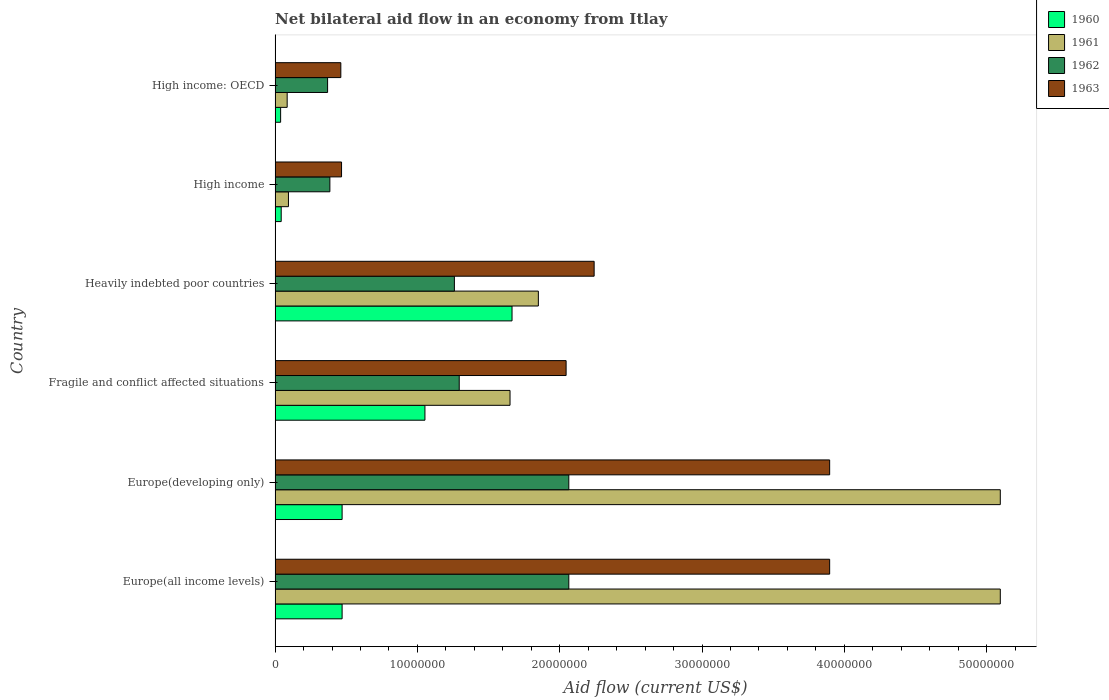Are the number of bars per tick equal to the number of legend labels?
Your answer should be very brief. Yes. How many bars are there on the 3rd tick from the bottom?
Keep it short and to the point. 4. What is the label of the 4th group of bars from the top?
Your response must be concise. Fragile and conflict affected situations. What is the net bilateral aid flow in 1961 in Heavily indebted poor countries?
Provide a succinct answer. 1.85e+07. Across all countries, what is the maximum net bilateral aid flow in 1963?
Ensure brevity in your answer.  3.90e+07. Across all countries, what is the minimum net bilateral aid flow in 1960?
Offer a terse response. 3.90e+05. In which country was the net bilateral aid flow in 1960 maximum?
Provide a succinct answer. Heavily indebted poor countries. In which country was the net bilateral aid flow in 1963 minimum?
Offer a very short reply. High income: OECD. What is the total net bilateral aid flow in 1962 in the graph?
Ensure brevity in your answer.  7.44e+07. What is the difference between the net bilateral aid flow in 1963 in Fragile and conflict affected situations and that in High income: OECD?
Provide a short and direct response. 1.58e+07. What is the difference between the net bilateral aid flow in 1960 in High income and the net bilateral aid flow in 1963 in Fragile and conflict affected situations?
Ensure brevity in your answer.  -2.00e+07. What is the average net bilateral aid flow in 1963 per country?
Keep it short and to the point. 2.17e+07. What is the difference between the net bilateral aid flow in 1962 and net bilateral aid flow in 1960 in High income?
Provide a short and direct response. 3.42e+06. What is the ratio of the net bilateral aid flow in 1961 in Europe(developing only) to that in Fragile and conflict affected situations?
Ensure brevity in your answer.  3.09. Is the difference between the net bilateral aid flow in 1962 in Europe(developing only) and High income greater than the difference between the net bilateral aid flow in 1960 in Europe(developing only) and High income?
Your answer should be very brief. Yes. What is the difference between the highest and the lowest net bilateral aid flow in 1960?
Your answer should be compact. 1.63e+07. What does the 3rd bar from the top in Europe(developing only) represents?
Your response must be concise. 1961. Is it the case that in every country, the sum of the net bilateral aid flow in 1960 and net bilateral aid flow in 1963 is greater than the net bilateral aid flow in 1962?
Provide a succinct answer. Yes. What is the difference between two consecutive major ticks on the X-axis?
Your response must be concise. 1.00e+07. Are the values on the major ticks of X-axis written in scientific E-notation?
Offer a very short reply. No. Does the graph contain any zero values?
Make the answer very short. No. Does the graph contain grids?
Ensure brevity in your answer.  No. How many legend labels are there?
Provide a short and direct response. 4. How are the legend labels stacked?
Ensure brevity in your answer.  Vertical. What is the title of the graph?
Offer a very short reply. Net bilateral aid flow in an economy from Itlay. What is the label or title of the X-axis?
Give a very brief answer. Aid flow (current US$). What is the Aid flow (current US$) of 1960 in Europe(all income levels)?
Your answer should be compact. 4.71e+06. What is the Aid flow (current US$) of 1961 in Europe(all income levels)?
Provide a succinct answer. 5.10e+07. What is the Aid flow (current US$) in 1962 in Europe(all income levels)?
Provide a short and direct response. 2.06e+07. What is the Aid flow (current US$) in 1963 in Europe(all income levels)?
Offer a terse response. 3.90e+07. What is the Aid flow (current US$) in 1960 in Europe(developing only)?
Provide a short and direct response. 4.71e+06. What is the Aid flow (current US$) in 1961 in Europe(developing only)?
Your response must be concise. 5.10e+07. What is the Aid flow (current US$) in 1962 in Europe(developing only)?
Give a very brief answer. 2.06e+07. What is the Aid flow (current US$) in 1963 in Europe(developing only)?
Your answer should be very brief. 3.90e+07. What is the Aid flow (current US$) in 1960 in Fragile and conflict affected situations?
Offer a very short reply. 1.05e+07. What is the Aid flow (current US$) of 1961 in Fragile and conflict affected situations?
Give a very brief answer. 1.65e+07. What is the Aid flow (current US$) of 1962 in Fragile and conflict affected situations?
Keep it short and to the point. 1.29e+07. What is the Aid flow (current US$) of 1963 in Fragile and conflict affected situations?
Make the answer very short. 2.04e+07. What is the Aid flow (current US$) of 1960 in Heavily indebted poor countries?
Ensure brevity in your answer.  1.66e+07. What is the Aid flow (current US$) in 1961 in Heavily indebted poor countries?
Give a very brief answer. 1.85e+07. What is the Aid flow (current US$) of 1962 in Heavily indebted poor countries?
Give a very brief answer. 1.26e+07. What is the Aid flow (current US$) of 1963 in Heavily indebted poor countries?
Provide a succinct answer. 2.24e+07. What is the Aid flow (current US$) in 1961 in High income?
Give a very brief answer. 9.40e+05. What is the Aid flow (current US$) of 1962 in High income?
Ensure brevity in your answer.  3.85e+06. What is the Aid flow (current US$) of 1963 in High income?
Make the answer very short. 4.67e+06. What is the Aid flow (current US$) in 1960 in High income: OECD?
Provide a short and direct response. 3.90e+05. What is the Aid flow (current US$) in 1961 in High income: OECD?
Your answer should be very brief. 8.50e+05. What is the Aid flow (current US$) of 1962 in High income: OECD?
Keep it short and to the point. 3.69e+06. What is the Aid flow (current US$) of 1963 in High income: OECD?
Your answer should be very brief. 4.62e+06. Across all countries, what is the maximum Aid flow (current US$) in 1960?
Ensure brevity in your answer.  1.66e+07. Across all countries, what is the maximum Aid flow (current US$) in 1961?
Provide a succinct answer. 5.10e+07. Across all countries, what is the maximum Aid flow (current US$) in 1962?
Ensure brevity in your answer.  2.06e+07. Across all countries, what is the maximum Aid flow (current US$) of 1963?
Provide a short and direct response. 3.90e+07. Across all countries, what is the minimum Aid flow (current US$) in 1961?
Ensure brevity in your answer.  8.50e+05. Across all countries, what is the minimum Aid flow (current US$) of 1962?
Make the answer very short. 3.69e+06. Across all countries, what is the minimum Aid flow (current US$) of 1963?
Give a very brief answer. 4.62e+06. What is the total Aid flow (current US$) of 1960 in the graph?
Keep it short and to the point. 3.74e+07. What is the total Aid flow (current US$) of 1961 in the graph?
Keep it short and to the point. 1.39e+08. What is the total Aid flow (current US$) of 1962 in the graph?
Your answer should be compact. 7.44e+07. What is the total Aid flow (current US$) in 1963 in the graph?
Make the answer very short. 1.30e+08. What is the difference between the Aid flow (current US$) in 1960 in Europe(all income levels) and that in Europe(developing only)?
Offer a very short reply. 0. What is the difference between the Aid flow (current US$) of 1962 in Europe(all income levels) and that in Europe(developing only)?
Keep it short and to the point. 0. What is the difference between the Aid flow (current US$) in 1960 in Europe(all income levels) and that in Fragile and conflict affected situations?
Offer a terse response. -5.82e+06. What is the difference between the Aid flow (current US$) of 1961 in Europe(all income levels) and that in Fragile and conflict affected situations?
Offer a terse response. 3.44e+07. What is the difference between the Aid flow (current US$) of 1962 in Europe(all income levels) and that in Fragile and conflict affected situations?
Your response must be concise. 7.70e+06. What is the difference between the Aid flow (current US$) of 1963 in Europe(all income levels) and that in Fragile and conflict affected situations?
Provide a succinct answer. 1.85e+07. What is the difference between the Aid flow (current US$) in 1960 in Europe(all income levels) and that in Heavily indebted poor countries?
Ensure brevity in your answer.  -1.19e+07. What is the difference between the Aid flow (current US$) in 1961 in Europe(all income levels) and that in Heavily indebted poor countries?
Your answer should be compact. 3.25e+07. What is the difference between the Aid flow (current US$) in 1962 in Europe(all income levels) and that in Heavily indebted poor countries?
Your answer should be very brief. 8.04e+06. What is the difference between the Aid flow (current US$) in 1963 in Europe(all income levels) and that in Heavily indebted poor countries?
Offer a terse response. 1.66e+07. What is the difference between the Aid flow (current US$) of 1960 in Europe(all income levels) and that in High income?
Ensure brevity in your answer.  4.28e+06. What is the difference between the Aid flow (current US$) in 1961 in Europe(all income levels) and that in High income?
Provide a succinct answer. 5.00e+07. What is the difference between the Aid flow (current US$) in 1962 in Europe(all income levels) and that in High income?
Provide a short and direct response. 1.68e+07. What is the difference between the Aid flow (current US$) in 1963 in Europe(all income levels) and that in High income?
Give a very brief answer. 3.43e+07. What is the difference between the Aid flow (current US$) in 1960 in Europe(all income levels) and that in High income: OECD?
Your response must be concise. 4.32e+06. What is the difference between the Aid flow (current US$) of 1961 in Europe(all income levels) and that in High income: OECD?
Your answer should be very brief. 5.01e+07. What is the difference between the Aid flow (current US$) in 1962 in Europe(all income levels) and that in High income: OECD?
Ensure brevity in your answer.  1.70e+07. What is the difference between the Aid flow (current US$) of 1963 in Europe(all income levels) and that in High income: OECD?
Offer a very short reply. 3.44e+07. What is the difference between the Aid flow (current US$) of 1960 in Europe(developing only) and that in Fragile and conflict affected situations?
Your answer should be very brief. -5.82e+06. What is the difference between the Aid flow (current US$) of 1961 in Europe(developing only) and that in Fragile and conflict affected situations?
Your answer should be very brief. 3.44e+07. What is the difference between the Aid flow (current US$) in 1962 in Europe(developing only) and that in Fragile and conflict affected situations?
Your answer should be very brief. 7.70e+06. What is the difference between the Aid flow (current US$) of 1963 in Europe(developing only) and that in Fragile and conflict affected situations?
Keep it short and to the point. 1.85e+07. What is the difference between the Aid flow (current US$) of 1960 in Europe(developing only) and that in Heavily indebted poor countries?
Your answer should be compact. -1.19e+07. What is the difference between the Aid flow (current US$) in 1961 in Europe(developing only) and that in Heavily indebted poor countries?
Keep it short and to the point. 3.25e+07. What is the difference between the Aid flow (current US$) in 1962 in Europe(developing only) and that in Heavily indebted poor countries?
Provide a short and direct response. 8.04e+06. What is the difference between the Aid flow (current US$) in 1963 in Europe(developing only) and that in Heavily indebted poor countries?
Your answer should be compact. 1.66e+07. What is the difference between the Aid flow (current US$) of 1960 in Europe(developing only) and that in High income?
Your response must be concise. 4.28e+06. What is the difference between the Aid flow (current US$) in 1961 in Europe(developing only) and that in High income?
Your answer should be very brief. 5.00e+07. What is the difference between the Aid flow (current US$) in 1962 in Europe(developing only) and that in High income?
Keep it short and to the point. 1.68e+07. What is the difference between the Aid flow (current US$) of 1963 in Europe(developing only) and that in High income?
Give a very brief answer. 3.43e+07. What is the difference between the Aid flow (current US$) of 1960 in Europe(developing only) and that in High income: OECD?
Ensure brevity in your answer.  4.32e+06. What is the difference between the Aid flow (current US$) in 1961 in Europe(developing only) and that in High income: OECD?
Your response must be concise. 5.01e+07. What is the difference between the Aid flow (current US$) in 1962 in Europe(developing only) and that in High income: OECD?
Offer a terse response. 1.70e+07. What is the difference between the Aid flow (current US$) of 1963 in Europe(developing only) and that in High income: OECD?
Give a very brief answer. 3.44e+07. What is the difference between the Aid flow (current US$) of 1960 in Fragile and conflict affected situations and that in Heavily indebted poor countries?
Offer a very short reply. -6.12e+06. What is the difference between the Aid flow (current US$) in 1961 in Fragile and conflict affected situations and that in Heavily indebted poor countries?
Keep it short and to the point. -1.99e+06. What is the difference between the Aid flow (current US$) in 1963 in Fragile and conflict affected situations and that in Heavily indebted poor countries?
Give a very brief answer. -1.97e+06. What is the difference between the Aid flow (current US$) in 1960 in Fragile and conflict affected situations and that in High income?
Give a very brief answer. 1.01e+07. What is the difference between the Aid flow (current US$) in 1961 in Fragile and conflict affected situations and that in High income?
Make the answer very short. 1.56e+07. What is the difference between the Aid flow (current US$) in 1962 in Fragile and conflict affected situations and that in High income?
Provide a short and direct response. 9.09e+06. What is the difference between the Aid flow (current US$) in 1963 in Fragile and conflict affected situations and that in High income?
Ensure brevity in your answer.  1.58e+07. What is the difference between the Aid flow (current US$) of 1960 in Fragile and conflict affected situations and that in High income: OECD?
Keep it short and to the point. 1.01e+07. What is the difference between the Aid flow (current US$) in 1961 in Fragile and conflict affected situations and that in High income: OECD?
Keep it short and to the point. 1.57e+07. What is the difference between the Aid flow (current US$) of 1962 in Fragile and conflict affected situations and that in High income: OECD?
Offer a very short reply. 9.25e+06. What is the difference between the Aid flow (current US$) of 1963 in Fragile and conflict affected situations and that in High income: OECD?
Give a very brief answer. 1.58e+07. What is the difference between the Aid flow (current US$) of 1960 in Heavily indebted poor countries and that in High income?
Offer a very short reply. 1.62e+07. What is the difference between the Aid flow (current US$) in 1961 in Heavily indebted poor countries and that in High income?
Offer a terse response. 1.76e+07. What is the difference between the Aid flow (current US$) in 1962 in Heavily indebted poor countries and that in High income?
Your answer should be compact. 8.75e+06. What is the difference between the Aid flow (current US$) of 1963 in Heavily indebted poor countries and that in High income?
Your response must be concise. 1.78e+07. What is the difference between the Aid flow (current US$) of 1960 in Heavily indebted poor countries and that in High income: OECD?
Ensure brevity in your answer.  1.63e+07. What is the difference between the Aid flow (current US$) of 1961 in Heavily indebted poor countries and that in High income: OECD?
Provide a succinct answer. 1.76e+07. What is the difference between the Aid flow (current US$) in 1962 in Heavily indebted poor countries and that in High income: OECD?
Ensure brevity in your answer.  8.91e+06. What is the difference between the Aid flow (current US$) of 1963 in Heavily indebted poor countries and that in High income: OECD?
Ensure brevity in your answer.  1.78e+07. What is the difference between the Aid flow (current US$) in 1961 in High income and that in High income: OECD?
Provide a succinct answer. 9.00e+04. What is the difference between the Aid flow (current US$) of 1963 in High income and that in High income: OECD?
Your answer should be compact. 5.00e+04. What is the difference between the Aid flow (current US$) of 1960 in Europe(all income levels) and the Aid flow (current US$) of 1961 in Europe(developing only)?
Your answer should be very brief. -4.62e+07. What is the difference between the Aid flow (current US$) of 1960 in Europe(all income levels) and the Aid flow (current US$) of 1962 in Europe(developing only)?
Provide a succinct answer. -1.59e+07. What is the difference between the Aid flow (current US$) in 1960 in Europe(all income levels) and the Aid flow (current US$) in 1963 in Europe(developing only)?
Your answer should be compact. -3.43e+07. What is the difference between the Aid flow (current US$) in 1961 in Europe(all income levels) and the Aid flow (current US$) in 1962 in Europe(developing only)?
Keep it short and to the point. 3.03e+07. What is the difference between the Aid flow (current US$) of 1961 in Europe(all income levels) and the Aid flow (current US$) of 1963 in Europe(developing only)?
Your answer should be compact. 1.20e+07. What is the difference between the Aid flow (current US$) in 1962 in Europe(all income levels) and the Aid flow (current US$) in 1963 in Europe(developing only)?
Your answer should be very brief. -1.83e+07. What is the difference between the Aid flow (current US$) of 1960 in Europe(all income levels) and the Aid flow (current US$) of 1961 in Fragile and conflict affected situations?
Make the answer very short. -1.18e+07. What is the difference between the Aid flow (current US$) of 1960 in Europe(all income levels) and the Aid flow (current US$) of 1962 in Fragile and conflict affected situations?
Make the answer very short. -8.23e+06. What is the difference between the Aid flow (current US$) in 1960 in Europe(all income levels) and the Aid flow (current US$) in 1963 in Fragile and conflict affected situations?
Keep it short and to the point. -1.57e+07. What is the difference between the Aid flow (current US$) in 1961 in Europe(all income levels) and the Aid flow (current US$) in 1962 in Fragile and conflict affected situations?
Ensure brevity in your answer.  3.80e+07. What is the difference between the Aid flow (current US$) in 1961 in Europe(all income levels) and the Aid flow (current US$) in 1963 in Fragile and conflict affected situations?
Provide a short and direct response. 3.05e+07. What is the difference between the Aid flow (current US$) of 1962 in Europe(all income levels) and the Aid flow (current US$) of 1963 in Fragile and conflict affected situations?
Provide a succinct answer. 1.90e+05. What is the difference between the Aid flow (current US$) in 1960 in Europe(all income levels) and the Aid flow (current US$) in 1961 in Heavily indebted poor countries?
Your response must be concise. -1.38e+07. What is the difference between the Aid flow (current US$) in 1960 in Europe(all income levels) and the Aid flow (current US$) in 1962 in Heavily indebted poor countries?
Your answer should be very brief. -7.89e+06. What is the difference between the Aid flow (current US$) in 1960 in Europe(all income levels) and the Aid flow (current US$) in 1963 in Heavily indebted poor countries?
Your answer should be very brief. -1.77e+07. What is the difference between the Aid flow (current US$) of 1961 in Europe(all income levels) and the Aid flow (current US$) of 1962 in Heavily indebted poor countries?
Your answer should be very brief. 3.84e+07. What is the difference between the Aid flow (current US$) in 1961 in Europe(all income levels) and the Aid flow (current US$) in 1963 in Heavily indebted poor countries?
Give a very brief answer. 2.85e+07. What is the difference between the Aid flow (current US$) in 1962 in Europe(all income levels) and the Aid flow (current US$) in 1963 in Heavily indebted poor countries?
Your answer should be very brief. -1.78e+06. What is the difference between the Aid flow (current US$) in 1960 in Europe(all income levels) and the Aid flow (current US$) in 1961 in High income?
Make the answer very short. 3.77e+06. What is the difference between the Aid flow (current US$) in 1960 in Europe(all income levels) and the Aid flow (current US$) in 1962 in High income?
Offer a terse response. 8.60e+05. What is the difference between the Aid flow (current US$) in 1960 in Europe(all income levels) and the Aid flow (current US$) in 1963 in High income?
Offer a very short reply. 4.00e+04. What is the difference between the Aid flow (current US$) of 1961 in Europe(all income levels) and the Aid flow (current US$) of 1962 in High income?
Offer a very short reply. 4.71e+07. What is the difference between the Aid flow (current US$) of 1961 in Europe(all income levels) and the Aid flow (current US$) of 1963 in High income?
Provide a succinct answer. 4.63e+07. What is the difference between the Aid flow (current US$) of 1962 in Europe(all income levels) and the Aid flow (current US$) of 1963 in High income?
Your answer should be very brief. 1.60e+07. What is the difference between the Aid flow (current US$) in 1960 in Europe(all income levels) and the Aid flow (current US$) in 1961 in High income: OECD?
Your answer should be very brief. 3.86e+06. What is the difference between the Aid flow (current US$) in 1960 in Europe(all income levels) and the Aid flow (current US$) in 1962 in High income: OECD?
Provide a succinct answer. 1.02e+06. What is the difference between the Aid flow (current US$) in 1960 in Europe(all income levels) and the Aid flow (current US$) in 1963 in High income: OECD?
Your response must be concise. 9.00e+04. What is the difference between the Aid flow (current US$) of 1961 in Europe(all income levels) and the Aid flow (current US$) of 1962 in High income: OECD?
Offer a very short reply. 4.73e+07. What is the difference between the Aid flow (current US$) in 1961 in Europe(all income levels) and the Aid flow (current US$) in 1963 in High income: OECD?
Provide a succinct answer. 4.63e+07. What is the difference between the Aid flow (current US$) in 1962 in Europe(all income levels) and the Aid flow (current US$) in 1963 in High income: OECD?
Ensure brevity in your answer.  1.60e+07. What is the difference between the Aid flow (current US$) in 1960 in Europe(developing only) and the Aid flow (current US$) in 1961 in Fragile and conflict affected situations?
Offer a very short reply. -1.18e+07. What is the difference between the Aid flow (current US$) of 1960 in Europe(developing only) and the Aid flow (current US$) of 1962 in Fragile and conflict affected situations?
Keep it short and to the point. -8.23e+06. What is the difference between the Aid flow (current US$) of 1960 in Europe(developing only) and the Aid flow (current US$) of 1963 in Fragile and conflict affected situations?
Offer a very short reply. -1.57e+07. What is the difference between the Aid flow (current US$) in 1961 in Europe(developing only) and the Aid flow (current US$) in 1962 in Fragile and conflict affected situations?
Offer a very short reply. 3.80e+07. What is the difference between the Aid flow (current US$) in 1961 in Europe(developing only) and the Aid flow (current US$) in 1963 in Fragile and conflict affected situations?
Keep it short and to the point. 3.05e+07. What is the difference between the Aid flow (current US$) of 1960 in Europe(developing only) and the Aid flow (current US$) of 1961 in Heavily indebted poor countries?
Offer a very short reply. -1.38e+07. What is the difference between the Aid flow (current US$) in 1960 in Europe(developing only) and the Aid flow (current US$) in 1962 in Heavily indebted poor countries?
Ensure brevity in your answer.  -7.89e+06. What is the difference between the Aid flow (current US$) in 1960 in Europe(developing only) and the Aid flow (current US$) in 1963 in Heavily indebted poor countries?
Your response must be concise. -1.77e+07. What is the difference between the Aid flow (current US$) of 1961 in Europe(developing only) and the Aid flow (current US$) of 1962 in Heavily indebted poor countries?
Give a very brief answer. 3.84e+07. What is the difference between the Aid flow (current US$) of 1961 in Europe(developing only) and the Aid flow (current US$) of 1963 in Heavily indebted poor countries?
Give a very brief answer. 2.85e+07. What is the difference between the Aid flow (current US$) in 1962 in Europe(developing only) and the Aid flow (current US$) in 1963 in Heavily indebted poor countries?
Give a very brief answer. -1.78e+06. What is the difference between the Aid flow (current US$) of 1960 in Europe(developing only) and the Aid flow (current US$) of 1961 in High income?
Make the answer very short. 3.77e+06. What is the difference between the Aid flow (current US$) in 1960 in Europe(developing only) and the Aid flow (current US$) in 1962 in High income?
Your answer should be very brief. 8.60e+05. What is the difference between the Aid flow (current US$) of 1960 in Europe(developing only) and the Aid flow (current US$) of 1963 in High income?
Provide a short and direct response. 4.00e+04. What is the difference between the Aid flow (current US$) of 1961 in Europe(developing only) and the Aid flow (current US$) of 1962 in High income?
Offer a very short reply. 4.71e+07. What is the difference between the Aid flow (current US$) in 1961 in Europe(developing only) and the Aid flow (current US$) in 1963 in High income?
Keep it short and to the point. 4.63e+07. What is the difference between the Aid flow (current US$) of 1962 in Europe(developing only) and the Aid flow (current US$) of 1963 in High income?
Offer a very short reply. 1.60e+07. What is the difference between the Aid flow (current US$) in 1960 in Europe(developing only) and the Aid flow (current US$) in 1961 in High income: OECD?
Provide a short and direct response. 3.86e+06. What is the difference between the Aid flow (current US$) in 1960 in Europe(developing only) and the Aid flow (current US$) in 1962 in High income: OECD?
Ensure brevity in your answer.  1.02e+06. What is the difference between the Aid flow (current US$) of 1960 in Europe(developing only) and the Aid flow (current US$) of 1963 in High income: OECD?
Your response must be concise. 9.00e+04. What is the difference between the Aid flow (current US$) of 1961 in Europe(developing only) and the Aid flow (current US$) of 1962 in High income: OECD?
Your answer should be very brief. 4.73e+07. What is the difference between the Aid flow (current US$) of 1961 in Europe(developing only) and the Aid flow (current US$) of 1963 in High income: OECD?
Keep it short and to the point. 4.63e+07. What is the difference between the Aid flow (current US$) in 1962 in Europe(developing only) and the Aid flow (current US$) in 1963 in High income: OECD?
Your answer should be compact. 1.60e+07. What is the difference between the Aid flow (current US$) of 1960 in Fragile and conflict affected situations and the Aid flow (current US$) of 1961 in Heavily indebted poor countries?
Make the answer very short. -7.97e+06. What is the difference between the Aid flow (current US$) in 1960 in Fragile and conflict affected situations and the Aid flow (current US$) in 1962 in Heavily indebted poor countries?
Provide a short and direct response. -2.07e+06. What is the difference between the Aid flow (current US$) of 1960 in Fragile and conflict affected situations and the Aid flow (current US$) of 1963 in Heavily indebted poor countries?
Ensure brevity in your answer.  -1.19e+07. What is the difference between the Aid flow (current US$) of 1961 in Fragile and conflict affected situations and the Aid flow (current US$) of 1962 in Heavily indebted poor countries?
Offer a terse response. 3.91e+06. What is the difference between the Aid flow (current US$) of 1961 in Fragile and conflict affected situations and the Aid flow (current US$) of 1963 in Heavily indebted poor countries?
Your answer should be very brief. -5.91e+06. What is the difference between the Aid flow (current US$) of 1962 in Fragile and conflict affected situations and the Aid flow (current US$) of 1963 in Heavily indebted poor countries?
Keep it short and to the point. -9.48e+06. What is the difference between the Aid flow (current US$) of 1960 in Fragile and conflict affected situations and the Aid flow (current US$) of 1961 in High income?
Provide a succinct answer. 9.59e+06. What is the difference between the Aid flow (current US$) of 1960 in Fragile and conflict affected situations and the Aid flow (current US$) of 1962 in High income?
Offer a very short reply. 6.68e+06. What is the difference between the Aid flow (current US$) of 1960 in Fragile and conflict affected situations and the Aid flow (current US$) of 1963 in High income?
Give a very brief answer. 5.86e+06. What is the difference between the Aid flow (current US$) in 1961 in Fragile and conflict affected situations and the Aid flow (current US$) in 1962 in High income?
Keep it short and to the point. 1.27e+07. What is the difference between the Aid flow (current US$) of 1961 in Fragile and conflict affected situations and the Aid flow (current US$) of 1963 in High income?
Provide a short and direct response. 1.18e+07. What is the difference between the Aid flow (current US$) of 1962 in Fragile and conflict affected situations and the Aid flow (current US$) of 1963 in High income?
Your answer should be compact. 8.27e+06. What is the difference between the Aid flow (current US$) of 1960 in Fragile and conflict affected situations and the Aid flow (current US$) of 1961 in High income: OECD?
Your answer should be compact. 9.68e+06. What is the difference between the Aid flow (current US$) in 1960 in Fragile and conflict affected situations and the Aid flow (current US$) in 1962 in High income: OECD?
Your answer should be very brief. 6.84e+06. What is the difference between the Aid flow (current US$) in 1960 in Fragile and conflict affected situations and the Aid flow (current US$) in 1963 in High income: OECD?
Offer a terse response. 5.91e+06. What is the difference between the Aid flow (current US$) of 1961 in Fragile and conflict affected situations and the Aid flow (current US$) of 1962 in High income: OECD?
Your response must be concise. 1.28e+07. What is the difference between the Aid flow (current US$) of 1961 in Fragile and conflict affected situations and the Aid flow (current US$) of 1963 in High income: OECD?
Offer a terse response. 1.19e+07. What is the difference between the Aid flow (current US$) in 1962 in Fragile and conflict affected situations and the Aid flow (current US$) in 1963 in High income: OECD?
Ensure brevity in your answer.  8.32e+06. What is the difference between the Aid flow (current US$) of 1960 in Heavily indebted poor countries and the Aid flow (current US$) of 1961 in High income?
Offer a very short reply. 1.57e+07. What is the difference between the Aid flow (current US$) in 1960 in Heavily indebted poor countries and the Aid flow (current US$) in 1962 in High income?
Provide a succinct answer. 1.28e+07. What is the difference between the Aid flow (current US$) of 1960 in Heavily indebted poor countries and the Aid flow (current US$) of 1963 in High income?
Ensure brevity in your answer.  1.20e+07. What is the difference between the Aid flow (current US$) in 1961 in Heavily indebted poor countries and the Aid flow (current US$) in 1962 in High income?
Your response must be concise. 1.46e+07. What is the difference between the Aid flow (current US$) of 1961 in Heavily indebted poor countries and the Aid flow (current US$) of 1963 in High income?
Ensure brevity in your answer.  1.38e+07. What is the difference between the Aid flow (current US$) in 1962 in Heavily indebted poor countries and the Aid flow (current US$) in 1963 in High income?
Offer a very short reply. 7.93e+06. What is the difference between the Aid flow (current US$) of 1960 in Heavily indebted poor countries and the Aid flow (current US$) of 1961 in High income: OECD?
Your answer should be very brief. 1.58e+07. What is the difference between the Aid flow (current US$) in 1960 in Heavily indebted poor countries and the Aid flow (current US$) in 1962 in High income: OECD?
Your response must be concise. 1.30e+07. What is the difference between the Aid flow (current US$) in 1960 in Heavily indebted poor countries and the Aid flow (current US$) in 1963 in High income: OECD?
Your answer should be compact. 1.20e+07. What is the difference between the Aid flow (current US$) in 1961 in Heavily indebted poor countries and the Aid flow (current US$) in 1962 in High income: OECD?
Provide a short and direct response. 1.48e+07. What is the difference between the Aid flow (current US$) of 1961 in Heavily indebted poor countries and the Aid flow (current US$) of 1963 in High income: OECD?
Provide a succinct answer. 1.39e+07. What is the difference between the Aid flow (current US$) of 1962 in Heavily indebted poor countries and the Aid flow (current US$) of 1963 in High income: OECD?
Ensure brevity in your answer.  7.98e+06. What is the difference between the Aid flow (current US$) in 1960 in High income and the Aid flow (current US$) in 1961 in High income: OECD?
Provide a succinct answer. -4.20e+05. What is the difference between the Aid flow (current US$) in 1960 in High income and the Aid flow (current US$) in 1962 in High income: OECD?
Your answer should be compact. -3.26e+06. What is the difference between the Aid flow (current US$) of 1960 in High income and the Aid flow (current US$) of 1963 in High income: OECD?
Your response must be concise. -4.19e+06. What is the difference between the Aid flow (current US$) of 1961 in High income and the Aid flow (current US$) of 1962 in High income: OECD?
Give a very brief answer. -2.75e+06. What is the difference between the Aid flow (current US$) in 1961 in High income and the Aid flow (current US$) in 1963 in High income: OECD?
Your response must be concise. -3.68e+06. What is the difference between the Aid flow (current US$) in 1962 in High income and the Aid flow (current US$) in 1963 in High income: OECD?
Keep it short and to the point. -7.70e+05. What is the average Aid flow (current US$) in 1960 per country?
Ensure brevity in your answer.  6.24e+06. What is the average Aid flow (current US$) of 1961 per country?
Ensure brevity in your answer.  2.31e+07. What is the average Aid flow (current US$) of 1962 per country?
Keep it short and to the point. 1.24e+07. What is the average Aid flow (current US$) in 1963 per country?
Make the answer very short. 2.17e+07. What is the difference between the Aid flow (current US$) in 1960 and Aid flow (current US$) in 1961 in Europe(all income levels)?
Provide a succinct answer. -4.62e+07. What is the difference between the Aid flow (current US$) of 1960 and Aid flow (current US$) of 1962 in Europe(all income levels)?
Offer a terse response. -1.59e+07. What is the difference between the Aid flow (current US$) in 1960 and Aid flow (current US$) in 1963 in Europe(all income levels)?
Give a very brief answer. -3.43e+07. What is the difference between the Aid flow (current US$) in 1961 and Aid flow (current US$) in 1962 in Europe(all income levels)?
Make the answer very short. 3.03e+07. What is the difference between the Aid flow (current US$) in 1961 and Aid flow (current US$) in 1963 in Europe(all income levels)?
Your response must be concise. 1.20e+07. What is the difference between the Aid flow (current US$) of 1962 and Aid flow (current US$) of 1963 in Europe(all income levels)?
Keep it short and to the point. -1.83e+07. What is the difference between the Aid flow (current US$) in 1960 and Aid flow (current US$) in 1961 in Europe(developing only)?
Keep it short and to the point. -4.62e+07. What is the difference between the Aid flow (current US$) in 1960 and Aid flow (current US$) in 1962 in Europe(developing only)?
Offer a terse response. -1.59e+07. What is the difference between the Aid flow (current US$) of 1960 and Aid flow (current US$) of 1963 in Europe(developing only)?
Keep it short and to the point. -3.43e+07. What is the difference between the Aid flow (current US$) in 1961 and Aid flow (current US$) in 1962 in Europe(developing only)?
Offer a terse response. 3.03e+07. What is the difference between the Aid flow (current US$) in 1961 and Aid flow (current US$) in 1963 in Europe(developing only)?
Your answer should be compact. 1.20e+07. What is the difference between the Aid flow (current US$) of 1962 and Aid flow (current US$) of 1963 in Europe(developing only)?
Keep it short and to the point. -1.83e+07. What is the difference between the Aid flow (current US$) of 1960 and Aid flow (current US$) of 1961 in Fragile and conflict affected situations?
Ensure brevity in your answer.  -5.98e+06. What is the difference between the Aid flow (current US$) in 1960 and Aid flow (current US$) in 1962 in Fragile and conflict affected situations?
Give a very brief answer. -2.41e+06. What is the difference between the Aid flow (current US$) in 1960 and Aid flow (current US$) in 1963 in Fragile and conflict affected situations?
Ensure brevity in your answer.  -9.92e+06. What is the difference between the Aid flow (current US$) in 1961 and Aid flow (current US$) in 1962 in Fragile and conflict affected situations?
Offer a very short reply. 3.57e+06. What is the difference between the Aid flow (current US$) in 1961 and Aid flow (current US$) in 1963 in Fragile and conflict affected situations?
Keep it short and to the point. -3.94e+06. What is the difference between the Aid flow (current US$) of 1962 and Aid flow (current US$) of 1963 in Fragile and conflict affected situations?
Provide a short and direct response. -7.51e+06. What is the difference between the Aid flow (current US$) in 1960 and Aid flow (current US$) in 1961 in Heavily indebted poor countries?
Provide a succinct answer. -1.85e+06. What is the difference between the Aid flow (current US$) of 1960 and Aid flow (current US$) of 1962 in Heavily indebted poor countries?
Offer a terse response. 4.05e+06. What is the difference between the Aid flow (current US$) of 1960 and Aid flow (current US$) of 1963 in Heavily indebted poor countries?
Keep it short and to the point. -5.77e+06. What is the difference between the Aid flow (current US$) of 1961 and Aid flow (current US$) of 1962 in Heavily indebted poor countries?
Offer a very short reply. 5.90e+06. What is the difference between the Aid flow (current US$) in 1961 and Aid flow (current US$) in 1963 in Heavily indebted poor countries?
Offer a very short reply. -3.92e+06. What is the difference between the Aid flow (current US$) of 1962 and Aid flow (current US$) of 1963 in Heavily indebted poor countries?
Give a very brief answer. -9.82e+06. What is the difference between the Aid flow (current US$) in 1960 and Aid flow (current US$) in 1961 in High income?
Provide a short and direct response. -5.10e+05. What is the difference between the Aid flow (current US$) of 1960 and Aid flow (current US$) of 1962 in High income?
Your answer should be compact. -3.42e+06. What is the difference between the Aid flow (current US$) of 1960 and Aid flow (current US$) of 1963 in High income?
Provide a short and direct response. -4.24e+06. What is the difference between the Aid flow (current US$) in 1961 and Aid flow (current US$) in 1962 in High income?
Your answer should be compact. -2.91e+06. What is the difference between the Aid flow (current US$) of 1961 and Aid flow (current US$) of 1963 in High income?
Offer a terse response. -3.73e+06. What is the difference between the Aid flow (current US$) in 1962 and Aid flow (current US$) in 1963 in High income?
Give a very brief answer. -8.20e+05. What is the difference between the Aid flow (current US$) in 1960 and Aid flow (current US$) in 1961 in High income: OECD?
Give a very brief answer. -4.60e+05. What is the difference between the Aid flow (current US$) in 1960 and Aid flow (current US$) in 1962 in High income: OECD?
Your answer should be very brief. -3.30e+06. What is the difference between the Aid flow (current US$) of 1960 and Aid flow (current US$) of 1963 in High income: OECD?
Keep it short and to the point. -4.23e+06. What is the difference between the Aid flow (current US$) of 1961 and Aid flow (current US$) of 1962 in High income: OECD?
Offer a terse response. -2.84e+06. What is the difference between the Aid flow (current US$) in 1961 and Aid flow (current US$) in 1963 in High income: OECD?
Make the answer very short. -3.77e+06. What is the difference between the Aid flow (current US$) in 1962 and Aid flow (current US$) in 1963 in High income: OECD?
Provide a short and direct response. -9.30e+05. What is the ratio of the Aid flow (current US$) of 1960 in Europe(all income levels) to that in Europe(developing only)?
Make the answer very short. 1. What is the ratio of the Aid flow (current US$) of 1961 in Europe(all income levels) to that in Europe(developing only)?
Offer a very short reply. 1. What is the ratio of the Aid flow (current US$) in 1962 in Europe(all income levels) to that in Europe(developing only)?
Provide a short and direct response. 1. What is the ratio of the Aid flow (current US$) in 1963 in Europe(all income levels) to that in Europe(developing only)?
Provide a short and direct response. 1. What is the ratio of the Aid flow (current US$) of 1960 in Europe(all income levels) to that in Fragile and conflict affected situations?
Ensure brevity in your answer.  0.45. What is the ratio of the Aid flow (current US$) of 1961 in Europe(all income levels) to that in Fragile and conflict affected situations?
Offer a terse response. 3.09. What is the ratio of the Aid flow (current US$) of 1962 in Europe(all income levels) to that in Fragile and conflict affected situations?
Offer a terse response. 1.6. What is the ratio of the Aid flow (current US$) in 1963 in Europe(all income levels) to that in Fragile and conflict affected situations?
Offer a terse response. 1.91. What is the ratio of the Aid flow (current US$) in 1960 in Europe(all income levels) to that in Heavily indebted poor countries?
Give a very brief answer. 0.28. What is the ratio of the Aid flow (current US$) in 1961 in Europe(all income levels) to that in Heavily indebted poor countries?
Your response must be concise. 2.75. What is the ratio of the Aid flow (current US$) of 1962 in Europe(all income levels) to that in Heavily indebted poor countries?
Ensure brevity in your answer.  1.64. What is the ratio of the Aid flow (current US$) of 1963 in Europe(all income levels) to that in Heavily indebted poor countries?
Your answer should be compact. 1.74. What is the ratio of the Aid flow (current US$) in 1960 in Europe(all income levels) to that in High income?
Ensure brevity in your answer.  10.95. What is the ratio of the Aid flow (current US$) in 1961 in Europe(all income levels) to that in High income?
Provide a succinct answer. 54.21. What is the ratio of the Aid flow (current US$) in 1962 in Europe(all income levels) to that in High income?
Keep it short and to the point. 5.36. What is the ratio of the Aid flow (current US$) of 1963 in Europe(all income levels) to that in High income?
Give a very brief answer. 8.34. What is the ratio of the Aid flow (current US$) of 1960 in Europe(all income levels) to that in High income: OECD?
Your answer should be compact. 12.08. What is the ratio of the Aid flow (current US$) in 1961 in Europe(all income levels) to that in High income: OECD?
Offer a terse response. 59.95. What is the ratio of the Aid flow (current US$) in 1962 in Europe(all income levels) to that in High income: OECD?
Your response must be concise. 5.59. What is the ratio of the Aid flow (current US$) of 1963 in Europe(all income levels) to that in High income: OECD?
Your answer should be compact. 8.44. What is the ratio of the Aid flow (current US$) in 1960 in Europe(developing only) to that in Fragile and conflict affected situations?
Your answer should be compact. 0.45. What is the ratio of the Aid flow (current US$) in 1961 in Europe(developing only) to that in Fragile and conflict affected situations?
Give a very brief answer. 3.09. What is the ratio of the Aid flow (current US$) in 1962 in Europe(developing only) to that in Fragile and conflict affected situations?
Your response must be concise. 1.6. What is the ratio of the Aid flow (current US$) of 1963 in Europe(developing only) to that in Fragile and conflict affected situations?
Give a very brief answer. 1.91. What is the ratio of the Aid flow (current US$) in 1960 in Europe(developing only) to that in Heavily indebted poor countries?
Your answer should be very brief. 0.28. What is the ratio of the Aid flow (current US$) of 1961 in Europe(developing only) to that in Heavily indebted poor countries?
Make the answer very short. 2.75. What is the ratio of the Aid flow (current US$) of 1962 in Europe(developing only) to that in Heavily indebted poor countries?
Provide a short and direct response. 1.64. What is the ratio of the Aid flow (current US$) of 1963 in Europe(developing only) to that in Heavily indebted poor countries?
Give a very brief answer. 1.74. What is the ratio of the Aid flow (current US$) in 1960 in Europe(developing only) to that in High income?
Provide a short and direct response. 10.95. What is the ratio of the Aid flow (current US$) of 1961 in Europe(developing only) to that in High income?
Ensure brevity in your answer.  54.21. What is the ratio of the Aid flow (current US$) of 1962 in Europe(developing only) to that in High income?
Your answer should be very brief. 5.36. What is the ratio of the Aid flow (current US$) of 1963 in Europe(developing only) to that in High income?
Offer a very short reply. 8.34. What is the ratio of the Aid flow (current US$) of 1960 in Europe(developing only) to that in High income: OECD?
Offer a terse response. 12.08. What is the ratio of the Aid flow (current US$) of 1961 in Europe(developing only) to that in High income: OECD?
Make the answer very short. 59.95. What is the ratio of the Aid flow (current US$) in 1962 in Europe(developing only) to that in High income: OECD?
Keep it short and to the point. 5.59. What is the ratio of the Aid flow (current US$) of 1963 in Europe(developing only) to that in High income: OECD?
Offer a terse response. 8.44. What is the ratio of the Aid flow (current US$) in 1960 in Fragile and conflict affected situations to that in Heavily indebted poor countries?
Provide a succinct answer. 0.63. What is the ratio of the Aid flow (current US$) in 1961 in Fragile and conflict affected situations to that in Heavily indebted poor countries?
Your response must be concise. 0.89. What is the ratio of the Aid flow (current US$) of 1963 in Fragile and conflict affected situations to that in Heavily indebted poor countries?
Provide a succinct answer. 0.91. What is the ratio of the Aid flow (current US$) of 1960 in Fragile and conflict affected situations to that in High income?
Provide a short and direct response. 24.49. What is the ratio of the Aid flow (current US$) in 1961 in Fragile and conflict affected situations to that in High income?
Provide a short and direct response. 17.56. What is the ratio of the Aid flow (current US$) of 1962 in Fragile and conflict affected situations to that in High income?
Give a very brief answer. 3.36. What is the ratio of the Aid flow (current US$) of 1963 in Fragile and conflict affected situations to that in High income?
Keep it short and to the point. 4.38. What is the ratio of the Aid flow (current US$) of 1960 in Fragile and conflict affected situations to that in High income: OECD?
Provide a short and direct response. 27. What is the ratio of the Aid flow (current US$) in 1961 in Fragile and conflict affected situations to that in High income: OECD?
Provide a short and direct response. 19.42. What is the ratio of the Aid flow (current US$) of 1962 in Fragile and conflict affected situations to that in High income: OECD?
Make the answer very short. 3.51. What is the ratio of the Aid flow (current US$) in 1963 in Fragile and conflict affected situations to that in High income: OECD?
Give a very brief answer. 4.43. What is the ratio of the Aid flow (current US$) in 1960 in Heavily indebted poor countries to that in High income?
Keep it short and to the point. 38.72. What is the ratio of the Aid flow (current US$) of 1961 in Heavily indebted poor countries to that in High income?
Your answer should be compact. 19.68. What is the ratio of the Aid flow (current US$) in 1962 in Heavily indebted poor countries to that in High income?
Your answer should be very brief. 3.27. What is the ratio of the Aid flow (current US$) in 1963 in Heavily indebted poor countries to that in High income?
Your answer should be very brief. 4.8. What is the ratio of the Aid flow (current US$) of 1960 in Heavily indebted poor countries to that in High income: OECD?
Your response must be concise. 42.69. What is the ratio of the Aid flow (current US$) in 1961 in Heavily indebted poor countries to that in High income: OECD?
Your response must be concise. 21.76. What is the ratio of the Aid flow (current US$) of 1962 in Heavily indebted poor countries to that in High income: OECD?
Your answer should be compact. 3.41. What is the ratio of the Aid flow (current US$) of 1963 in Heavily indebted poor countries to that in High income: OECD?
Provide a succinct answer. 4.85. What is the ratio of the Aid flow (current US$) in 1960 in High income to that in High income: OECD?
Give a very brief answer. 1.1. What is the ratio of the Aid flow (current US$) of 1961 in High income to that in High income: OECD?
Your answer should be compact. 1.11. What is the ratio of the Aid flow (current US$) in 1962 in High income to that in High income: OECD?
Your answer should be compact. 1.04. What is the ratio of the Aid flow (current US$) in 1963 in High income to that in High income: OECD?
Provide a succinct answer. 1.01. What is the difference between the highest and the second highest Aid flow (current US$) in 1960?
Your response must be concise. 6.12e+06. What is the difference between the highest and the lowest Aid flow (current US$) of 1960?
Give a very brief answer. 1.63e+07. What is the difference between the highest and the lowest Aid flow (current US$) in 1961?
Your response must be concise. 5.01e+07. What is the difference between the highest and the lowest Aid flow (current US$) of 1962?
Your answer should be very brief. 1.70e+07. What is the difference between the highest and the lowest Aid flow (current US$) in 1963?
Give a very brief answer. 3.44e+07. 